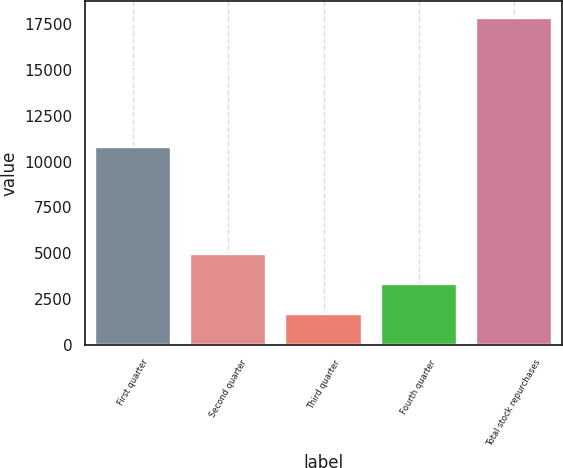Convert chart to OTSL. <chart><loc_0><loc_0><loc_500><loc_500><bar_chart><fcel>First quarter<fcel>Second quarter<fcel>Third quarter<fcel>Fourth quarter<fcel>Total stock repurchases<nl><fcel>10787<fcel>4941.4<fcel>1713<fcel>3327.2<fcel>17855<nl></chart> 